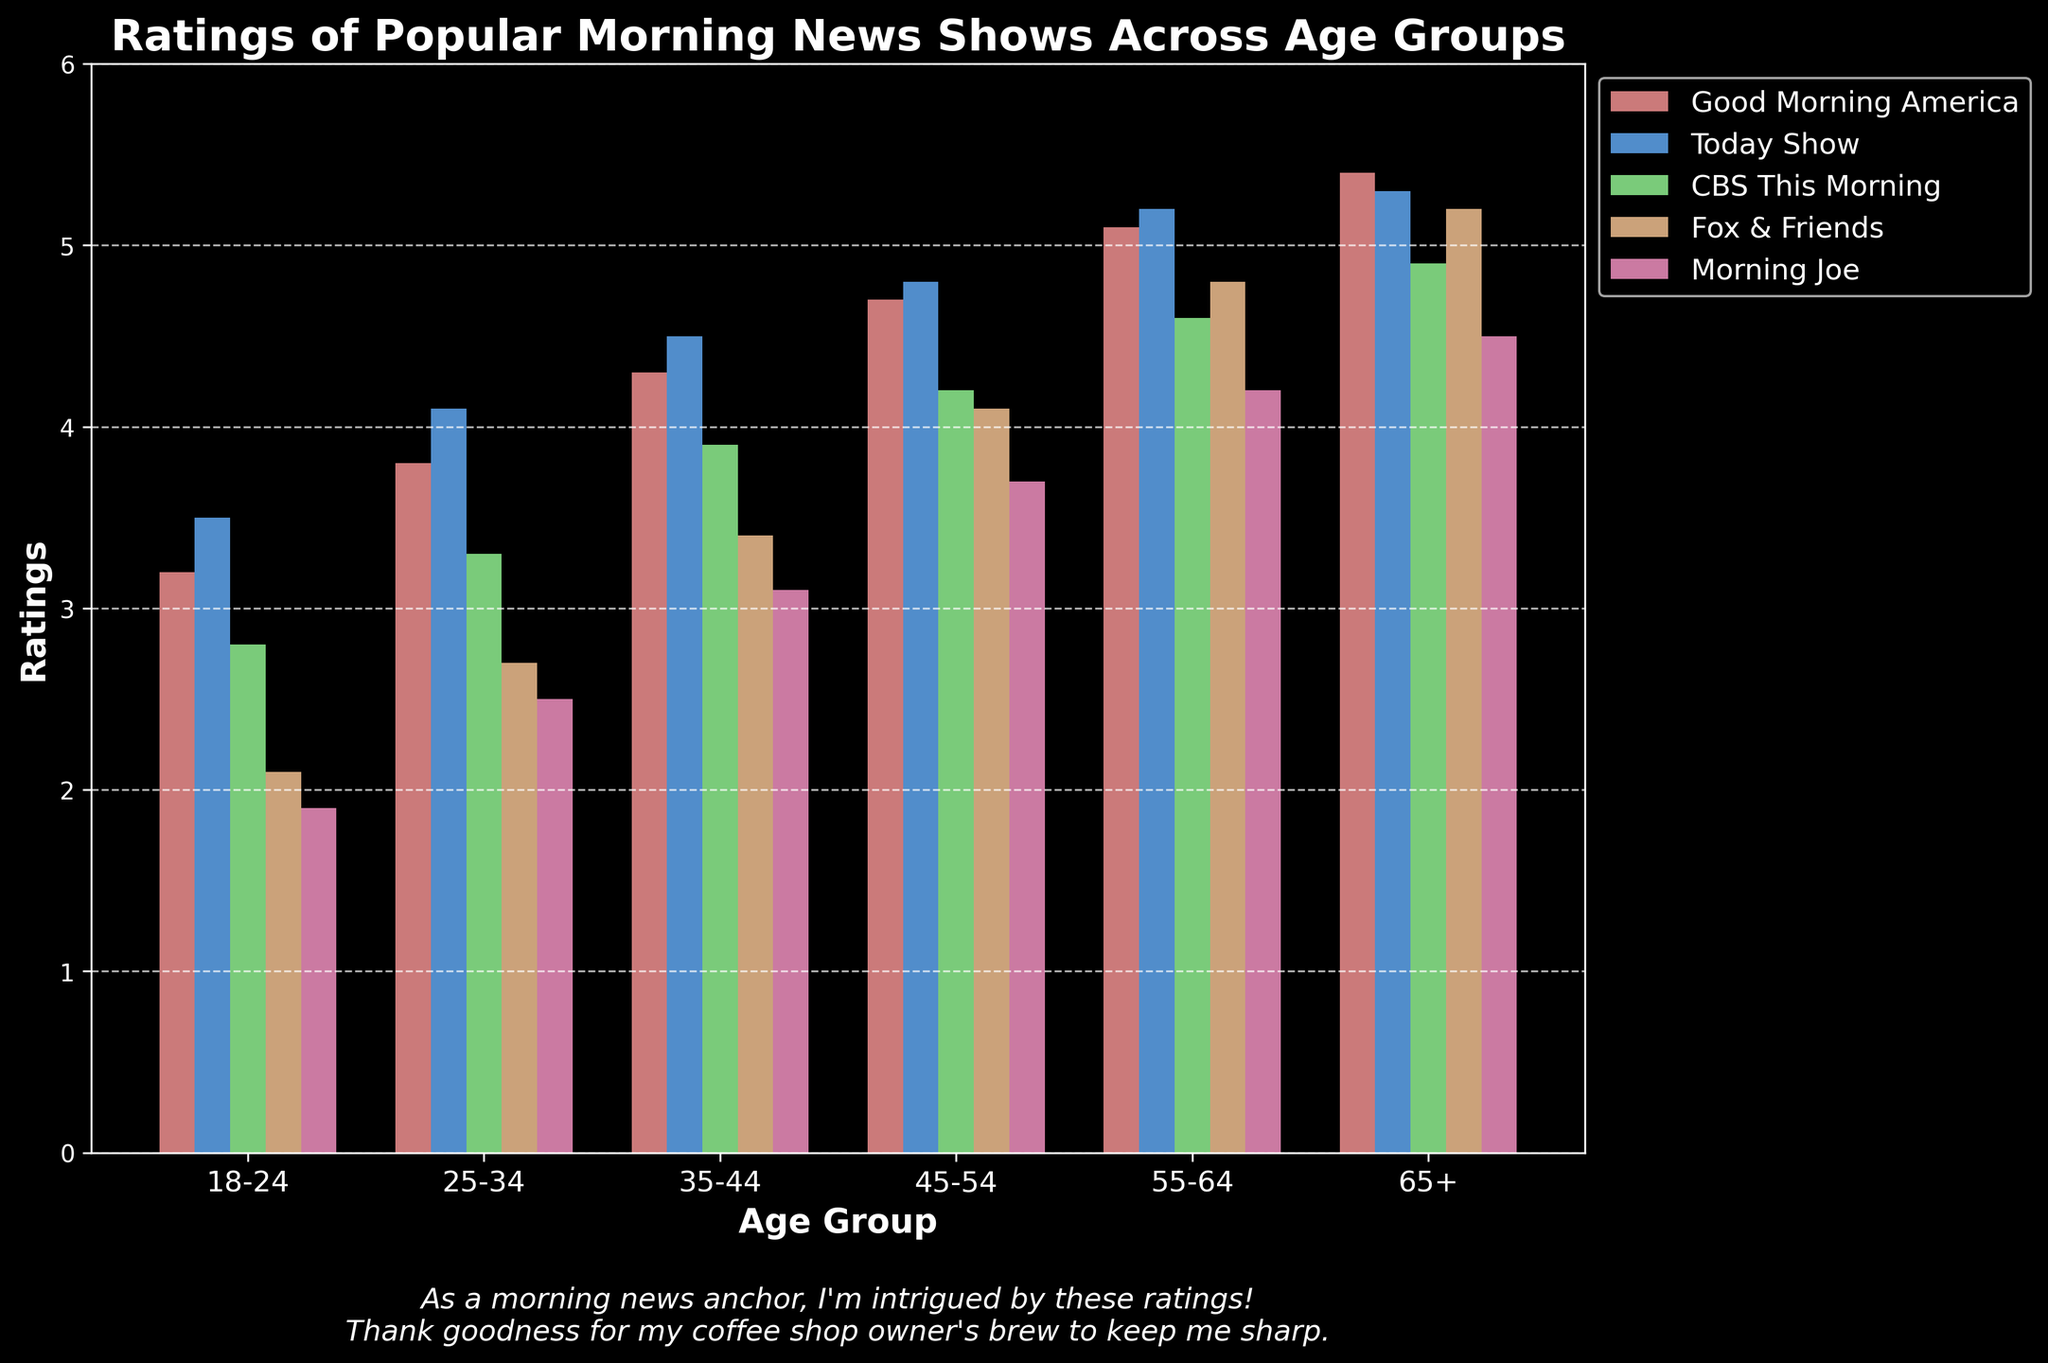Which age group gives the highest rating to the "Today Show"? Look at the bars corresponding to the "Today Show" in the chart and identify the tallest one. The tallest bar is in the age group 55-64.
Answer: 55-64 Which show has the lowest rating among the 18-24 age group? Locate the bars for the 18-24 age group and identify the shortest one. The shortest bar is for "Morning Joe".
Answer: Morning Joe How much higher is the rating of "Good Morning America" compared to "CBS This Morning" in the 65+ age group? Identify the bars for "Good Morning America" and "CBS This Morning" in the 65+ age group and calculate the difference: 5.4 - 4.9 = 0.5.
Answer: 0.5 What's the average rating of "Fox & Friends" across all age groups? Add the ratings of "Fox & Friends" from all age groups: 2.1 + 2.7 + 3.4 + 4.1 + 4.8 + 5.2 = 22.3. Then, divide by the number of age groups, which is 6: 22.3 / 6 ≈ 3.72.
Answer: 3.72 Between the 25-34 and 35-44 age groups, which one gives a higher rating to "Morning Joe"? Compare the height of the bars for "Morning Joe" in the 25-34 and 35-44 age groups. The rating is higher in the 35-44 age group.
Answer: 35-44 In which age group is the difference between "Good Morning America" and "Today Show" the smallest? Calculate the difference between the ratings of "Good Morning America" and "Today Show" for each age group, then identify which difference is the smallest:
18-24: 3.5 - 3.2 = 0.3,
25-34: 4.1 - 3.8 = 0.3,
35-44: 4.5 - 4.3 = 0.2,
45-54: 4.8 - 4.7 = 0.1,
55-64: 5.2 - 5.1 = 0.1,
65+: 5.3 - 5.4 = -0.1.
The smallest difference is -0.1 (absolute value 0.1) in the 65+ age group.
Answer: 65+ Which show has the most consistent ratings across all age groups? Assess the visual heights of the bars for each show across the age groups and identify which one has the most similar heights throughout. "Today Show" appears to have the most consistent ratings.
Answer: Today Show Is "CBS This Morning" more popular among the younger or older age groups? Compare the height of the bars for "CBS This Morning" between the younger age groups (18-24 and 25-34) and older age groups (55-64 and 65+). The ratings are higher in the older age groups.
Answer: Older In which age group does "Fox & Friends" see the largest increase in ratings compared to the previous age group? Check the bars corresponding to "Fox & Friends" and calculate the increase between consecutive age groups:
25-34: 2.7 - 2.1 = 0.6,
35-44: 3.4 - 2.7 = 0.7,
45-54: 4.1 - 3.4 = 0.7,
55-64: 4.8 - 4.1 = 0.7,
65+: 5.2 - 4.8 = 0.4.
The largest increase is observed between the age groups of 55-64 and 65+.
Answer: 45-54 